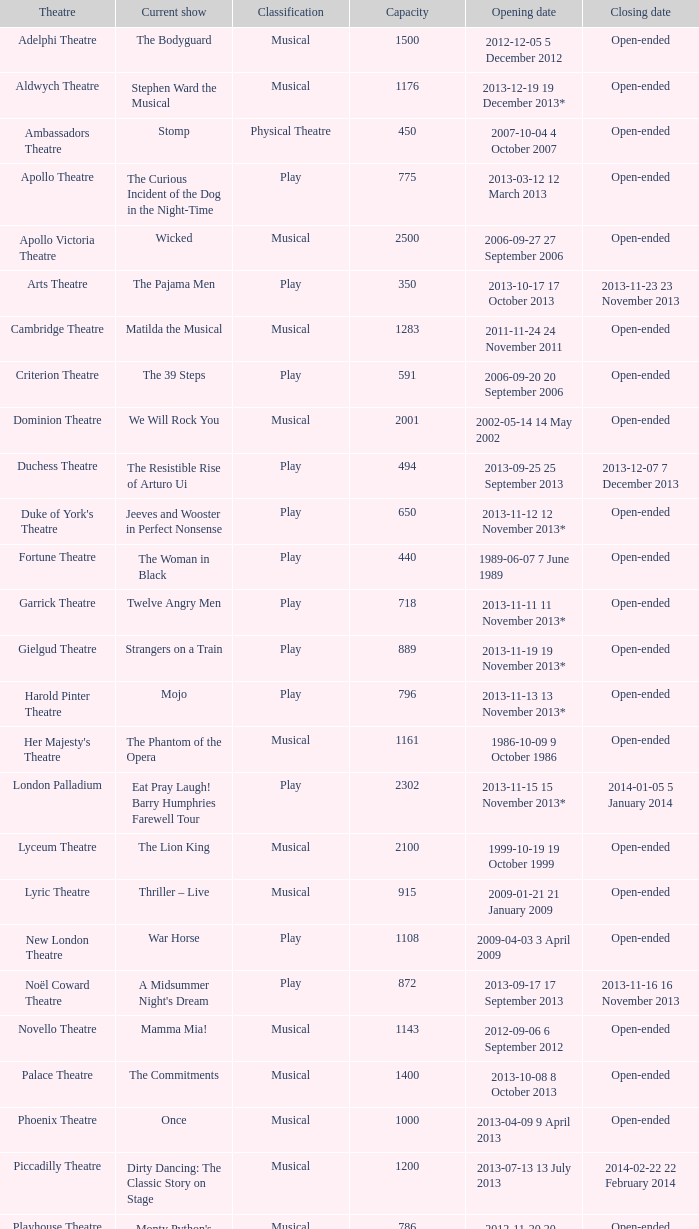What commencement date has a limit of 100? 2013-11-01 1 November 2013. 